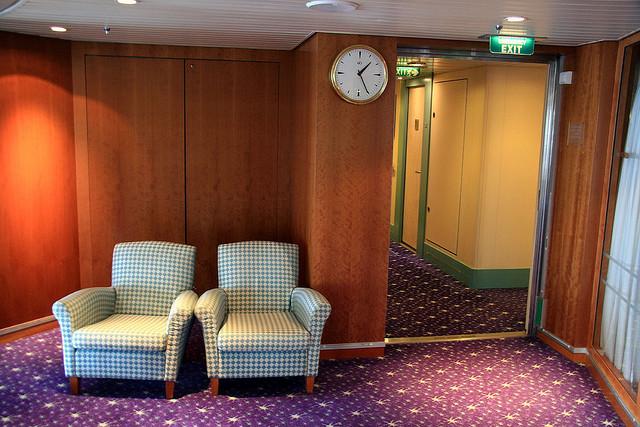Is there wall-to-wall carpeting on the floor?
Keep it brief. Yes. What time is it?
Be succinct. 1:25. Is this a lobby?
Concise answer only. Yes. 